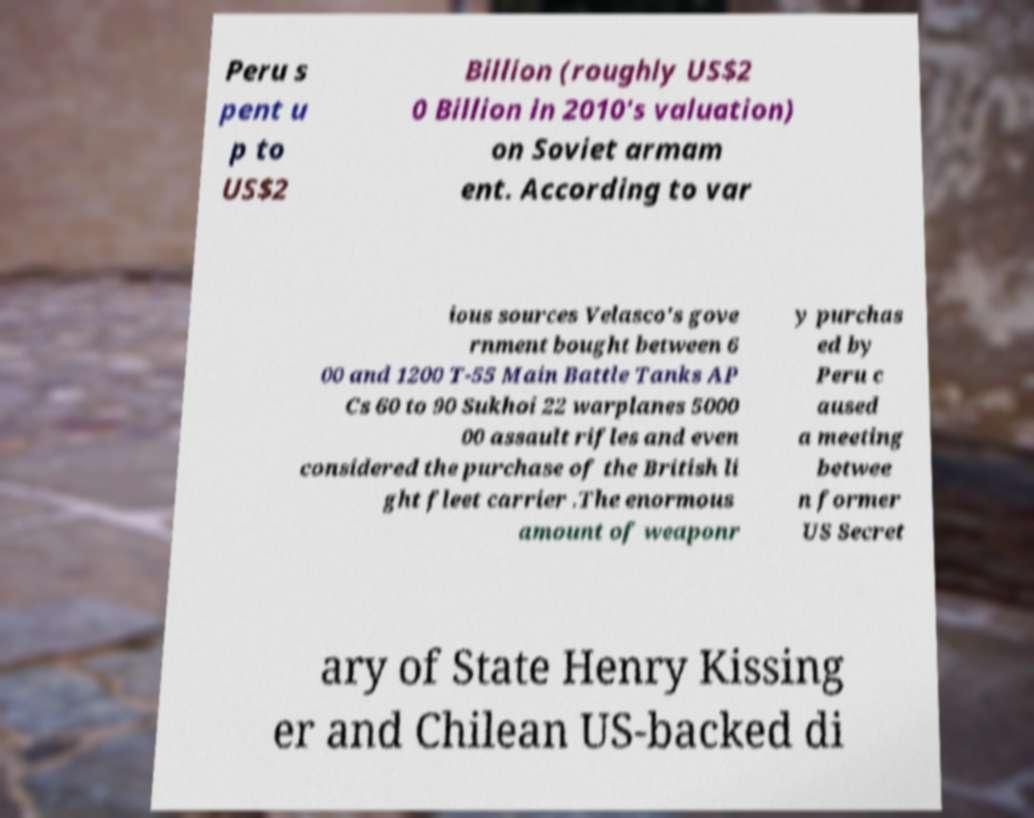I need the written content from this picture converted into text. Can you do that? Peru s pent u p to US$2 Billion (roughly US$2 0 Billion in 2010's valuation) on Soviet armam ent. According to var ious sources Velasco's gove rnment bought between 6 00 and 1200 T-55 Main Battle Tanks AP Cs 60 to 90 Sukhoi 22 warplanes 5000 00 assault rifles and even considered the purchase of the British li ght fleet carrier .The enormous amount of weaponr y purchas ed by Peru c aused a meeting betwee n former US Secret ary of State Henry Kissing er and Chilean US-backed di 